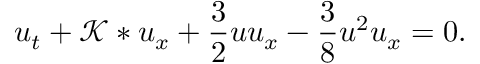<formula> <loc_0><loc_0><loc_500><loc_500>u _ { t } + \mathcal { K } * u _ { x } + \frac { 3 } { 2 } u u _ { x } - \frac { 3 } { 8 } u ^ { 2 } u _ { x } = 0 .</formula> 